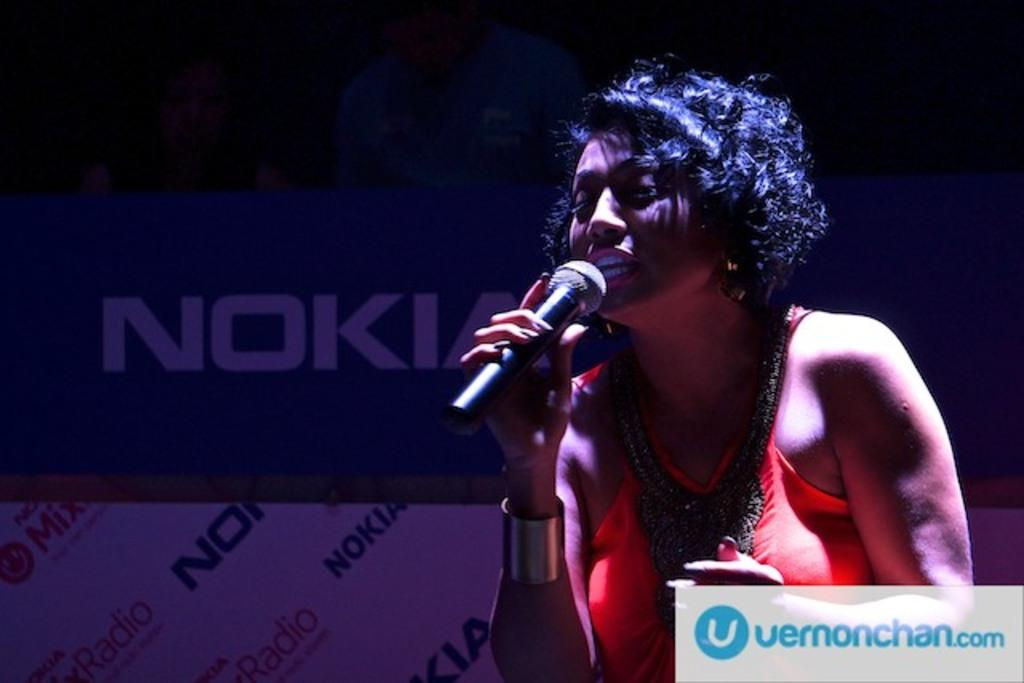Who is the main subject in the image? There is a woman in the image. What is the woman holding in the image? The woman is holding a microphone. What is the woman doing with the microphone? The woman is talking into the microphone. What can be seen on the poster in the image? The poster displays the NOKIA logo. Where is the lumber stored in the image? There is no lumber present in the image. What type of food is being served in the lunchroom in the image? There is no lunchroom present in the image. 